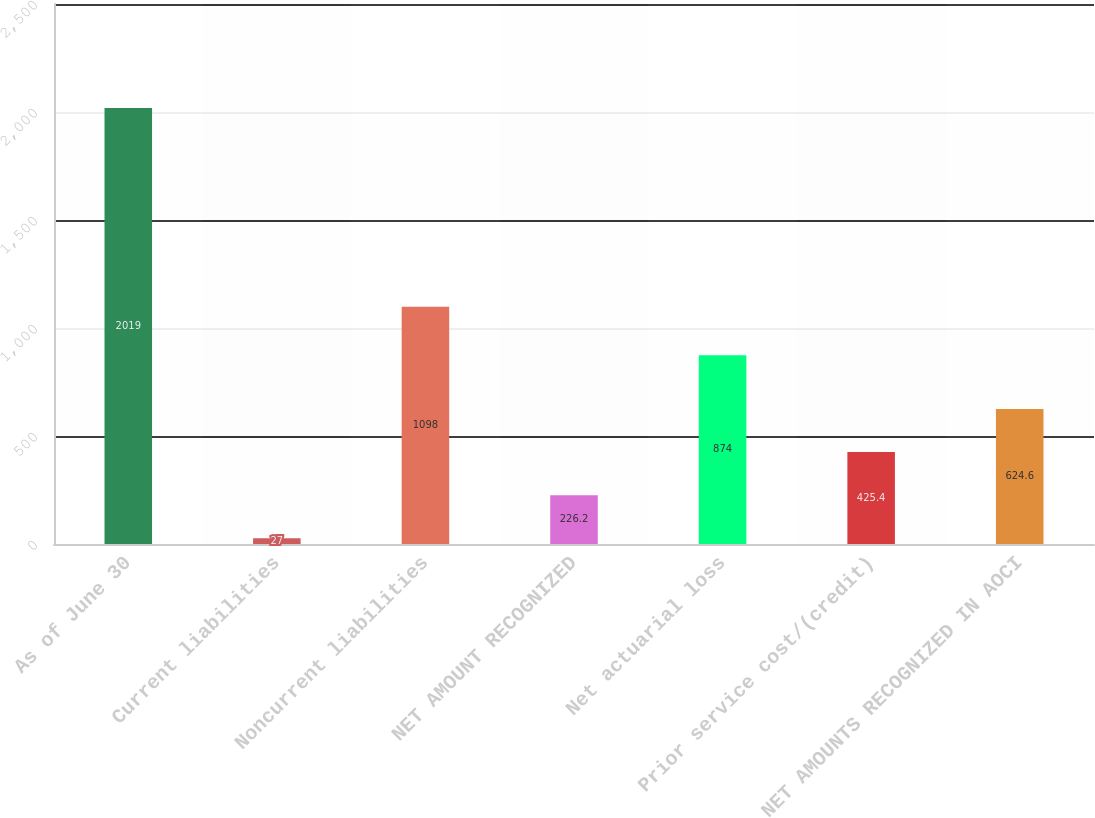Convert chart to OTSL. <chart><loc_0><loc_0><loc_500><loc_500><bar_chart><fcel>As of June 30<fcel>Current liabilities<fcel>Noncurrent liabilities<fcel>NET AMOUNT RECOGNIZED<fcel>Net actuarial loss<fcel>Prior service cost/(credit)<fcel>NET AMOUNTS RECOGNIZED IN AOCI<nl><fcel>2019<fcel>27<fcel>1098<fcel>226.2<fcel>874<fcel>425.4<fcel>624.6<nl></chart> 